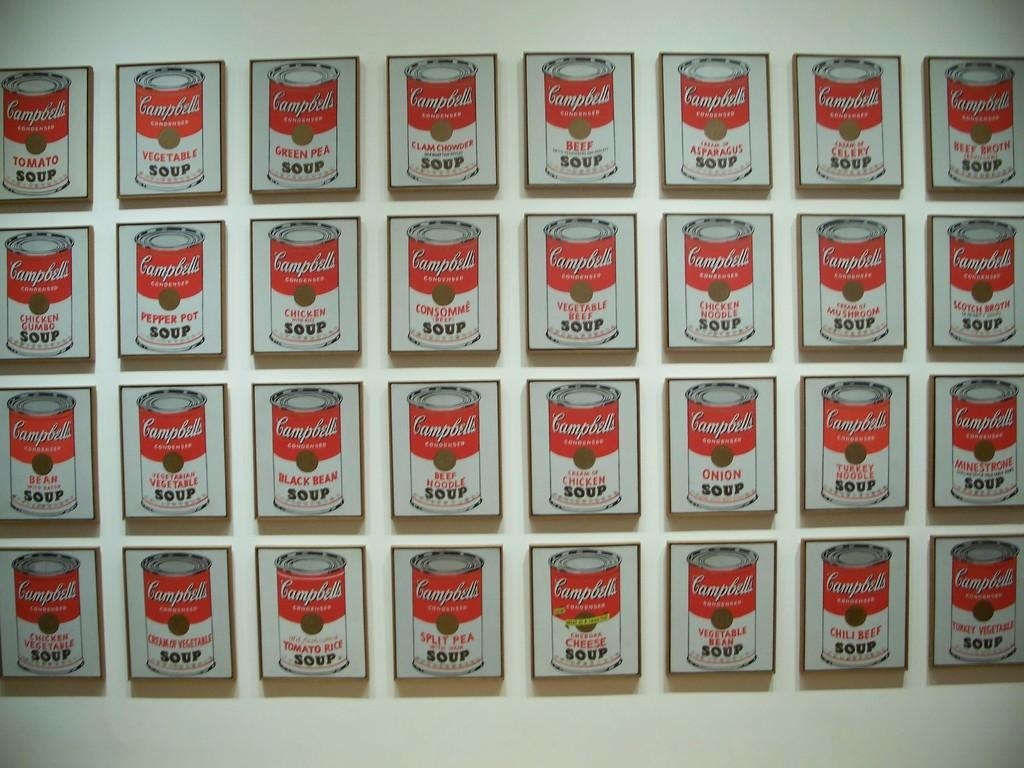<image>
Offer a succinct explanation of the picture presented. A wall with many paintings of Campbell's condensed soup. 